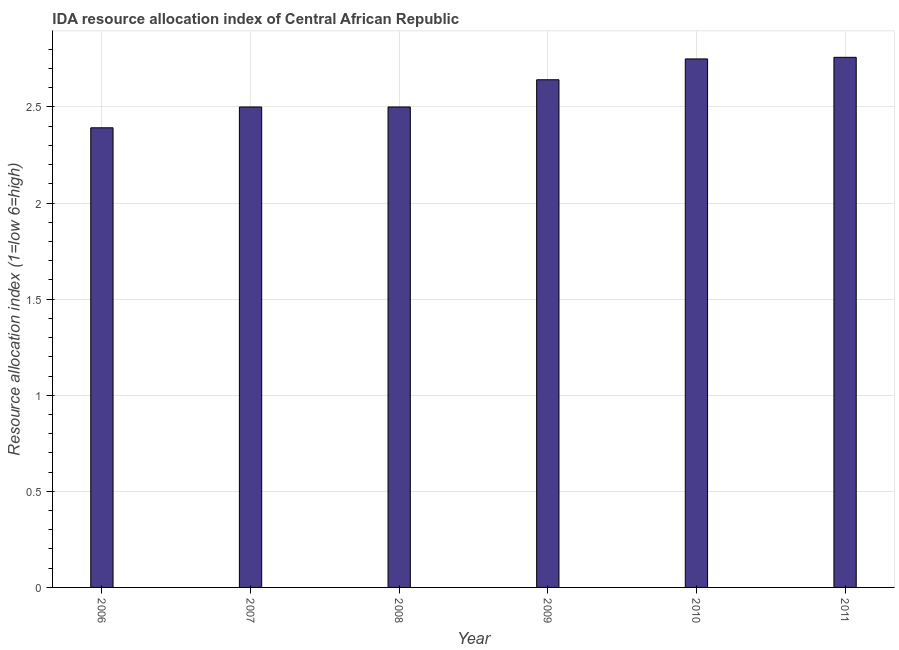Does the graph contain grids?
Provide a short and direct response. Yes. What is the title of the graph?
Offer a terse response. IDA resource allocation index of Central African Republic. What is the label or title of the Y-axis?
Your answer should be very brief. Resource allocation index (1=low 6=high). Across all years, what is the maximum ida resource allocation index?
Give a very brief answer. 2.76. Across all years, what is the minimum ida resource allocation index?
Ensure brevity in your answer.  2.39. In which year was the ida resource allocation index maximum?
Ensure brevity in your answer.  2011. In which year was the ida resource allocation index minimum?
Offer a terse response. 2006. What is the sum of the ida resource allocation index?
Offer a terse response. 15.54. What is the difference between the ida resource allocation index in 2006 and 2007?
Offer a terse response. -0.11. What is the average ida resource allocation index per year?
Give a very brief answer. 2.59. What is the median ida resource allocation index?
Provide a short and direct response. 2.57. Do a majority of the years between 2008 and 2006 (inclusive) have ida resource allocation index greater than 1.4 ?
Offer a very short reply. Yes. What is the ratio of the ida resource allocation index in 2006 to that in 2011?
Your answer should be compact. 0.87. What is the difference between the highest and the second highest ida resource allocation index?
Offer a terse response. 0.01. What is the difference between the highest and the lowest ida resource allocation index?
Your answer should be very brief. 0.37. In how many years, is the ida resource allocation index greater than the average ida resource allocation index taken over all years?
Offer a very short reply. 3. How many bars are there?
Make the answer very short. 6. How many years are there in the graph?
Ensure brevity in your answer.  6. What is the difference between two consecutive major ticks on the Y-axis?
Your response must be concise. 0.5. What is the Resource allocation index (1=low 6=high) of 2006?
Offer a terse response. 2.39. What is the Resource allocation index (1=low 6=high) of 2007?
Offer a terse response. 2.5. What is the Resource allocation index (1=low 6=high) in 2009?
Your answer should be compact. 2.64. What is the Resource allocation index (1=low 6=high) of 2010?
Your answer should be compact. 2.75. What is the Resource allocation index (1=low 6=high) of 2011?
Keep it short and to the point. 2.76. What is the difference between the Resource allocation index (1=low 6=high) in 2006 and 2007?
Your response must be concise. -0.11. What is the difference between the Resource allocation index (1=low 6=high) in 2006 and 2008?
Ensure brevity in your answer.  -0.11. What is the difference between the Resource allocation index (1=low 6=high) in 2006 and 2010?
Give a very brief answer. -0.36. What is the difference between the Resource allocation index (1=low 6=high) in 2006 and 2011?
Give a very brief answer. -0.37. What is the difference between the Resource allocation index (1=low 6=high) in 2007 and 2008?
Offer a very short reply. 0. What is the difference between the Resource allocation index (1=low 6=high) in 2007 and 2009?
Your answer should be very brief. -0.14. What is the difference between the Resource allocation index (1=low 6=high) in 2007 and 2011?
Offer a very short reply. -0.26. What is the difference between the Resource allocation index (1=low 6=high) in 2008 and 2009?
Keep it short and to the point. -0.14. What is the difference between the Resource allocation index (1=low 6=high) in 2008 and 2010?
Offer a very short reply. -0.25. What is the difference between the Resource allocation index (1=low 6=high) in 2008 and 2011?
Make the answer very short. -0.26. What is the difference between the Resource allocation index (1=low 6=high) in 2009 and 2010?
Offer a terse response. -0.11. What is the difference between the Resource allocation index (1=low 6=high) in 2009 and 2011?
Keep it short and to the point. -0.12. What is the difference between the Resource allocation index (1=low 6=high) in 2010 and 2011?
Give a very brief answer. -0.01. What is the ratio of the Resource allocation index (1=low 6=high) in 2006 to that in 2008?
Offer a very short reply. 0.96. What is the ratio of the Resource allocation index (1=low 6=high) in 2006 to that in 2009?
Keep it short and to the point. 0.91. What is the ratio of the Resource allocation index (1=low 6=high) in 2006 to that in 2010?
Offer a very short reply. 0.87. What is the ratio of the Resource allocation index (1=low 6=high) in 2006 to that in 2011?
Provide a short and direct response. 0.87. What is the ratio of the Resource allocation index (1=low 6=high) in 2007 to that in 2009?
Ensure brevity in your answer.  0.95. What is the ratio of the Resource allocation index (1=low 6=high) in 2007 to that in 2010?
Offer a terse response. 0.91. What is the ratio of the Resource allocation index (1=low 6=high) in 2007 to that in 2011?
Offer a terse response. 0.91. What is the ratio of the Resource allocation index (1=low 6=high) in 2008 to that in 2009?
Your answer should be very brief. 0.95. What is the ratio of the Resource allocation index (1=low 6=high) in 2008 to that in 2010?
Your answer should be compact. 0.91. What is the ratio of the Resource allocation index (1=low 6=high) in 2008 to that in 2011?
Offer a terse response. 0.91. What is the ratio of the Resource allocation index (1=low 6=high) in 2009 to that in 2010?
Make the answer very short. 0.96. What is the ratio of the Resource allocation index (1=low 6=high) in 2009 to that in 2011?
Your response must be concise. 0.96. 